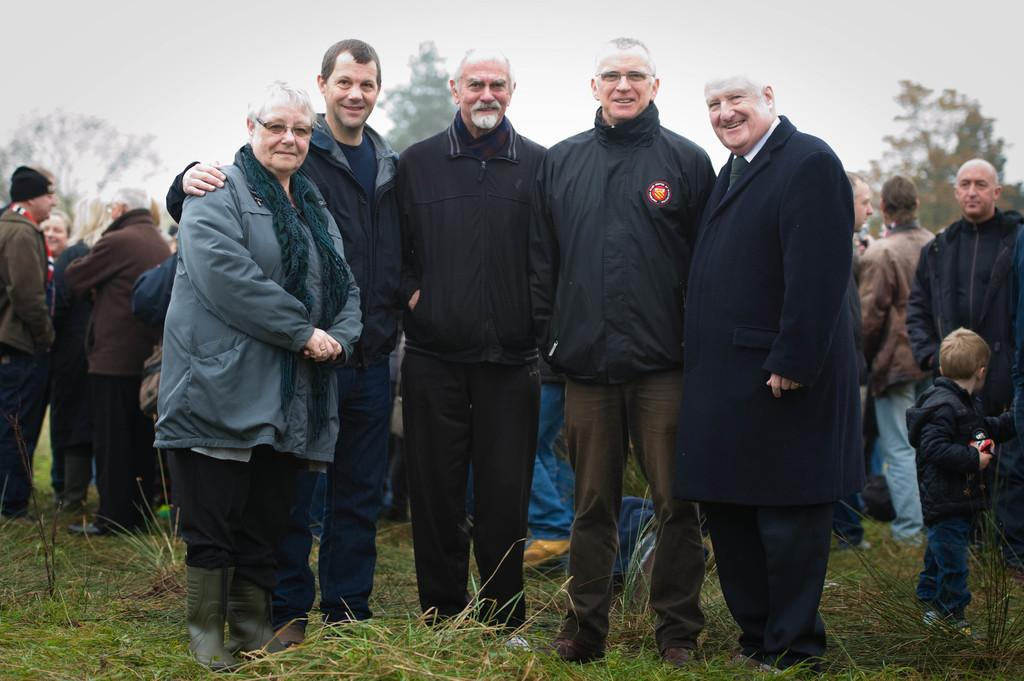How many people are standing on the ground in the image? There are five persons standing on the ground in the image. What type of vegetation is visible at the bottom of the image? There is grass visible at the bottom of the image. Can you describe the background of the image? In the background of the image, there are additional persons, trees, and the sky visible. Where is the kid located in the image? The kid is on the right side of the image. What color is the dress worn by the donkey in the image? There is no donkey or dress present in the image. What time of day is depicted in the image, based on the hour? The provided facts do not mention the time of day or any specific hour, so it cannot be determined from the image. 